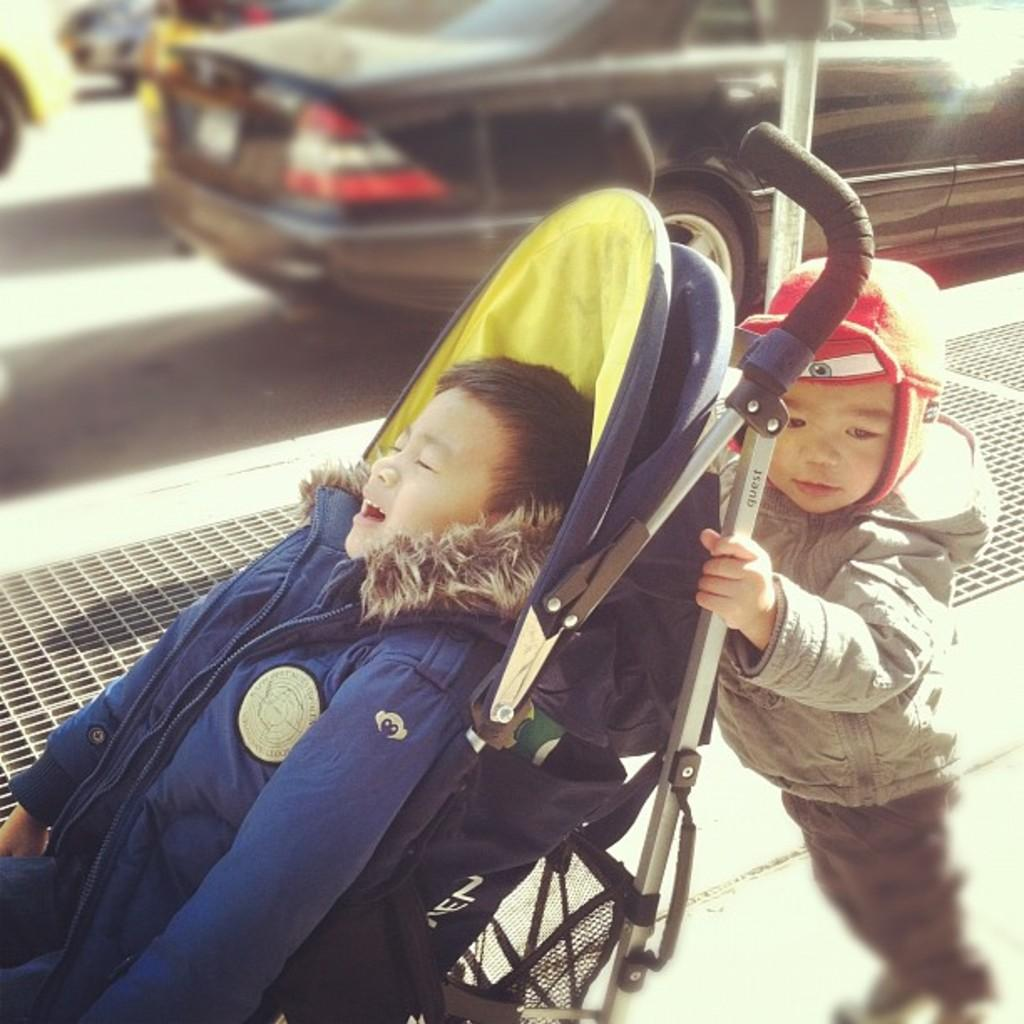What is the kid doing in the image? The kid is lying on a baby carrier. Who is supporting the baby carrier? Another kid is holding the rod of the baby carrier. What can be seen in the background of the image? There is a road in the background of the image. What is happening on the road? There are vehicles on the road. What type of voice can be heard coming from the kid on the baby carrier? There is no indication of any sound or voice in the image, so it cannot be determined. 